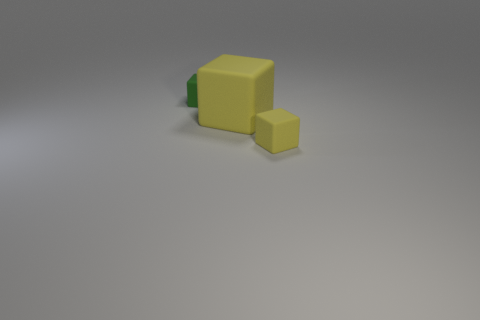Add 2 tiny green matte blocks. How many objects exist? 5 Subtract 3 cubes. How many cubes are left? 0 Subtract all tiny rubber blocks. How many blocks are left? 1 Subtract all brown spheres. How many purple blocks are left? 0 Subtract all tiny rubber cubes. Subtract all brown metal balls. How many objects are left? 1 Add 1 small green objects. How many small green objects are left? 2 Add 2 large cylinders. How many large cylinders exist? 2 Subtract all yellow cubes. How many cubes are left? 1 Subtract 0 red cubes. How many objects are left? 3 Subtract all gray blocks. Subtract all cyan spheres. How many blocks are left? 3 